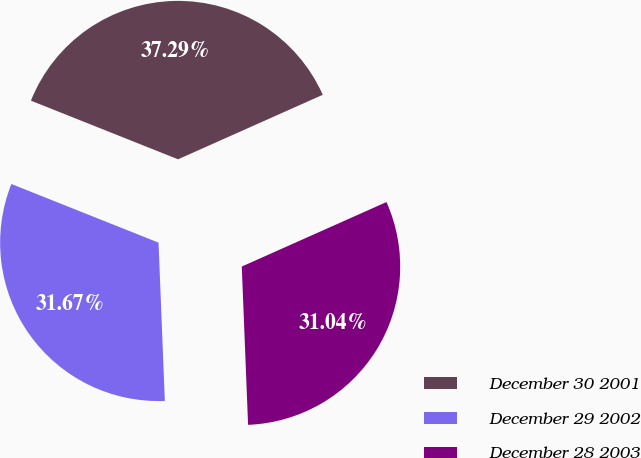<chart> <loc_0><loc_0><loc_500><loc_500><pie_chart><fcel>December 30 2001<fcel>December 29 2002<fcel>December 28 2003<nl><fcel>37.29%<fcel>31.67%<fcel>31.04%<nl></chart> 